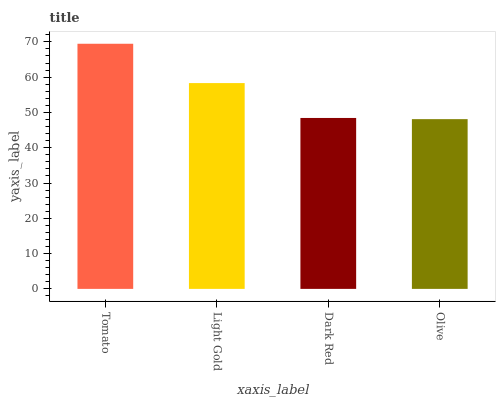Is Olive the minimum?
Answer yes or no. Yes. Is Tomato the maximum?
Answer yes or no. Yes. Is Light Gold the minimum?
Answer yes or no. No. Is Light Gold the maximum?
Answer yes or no. No. Is Tomato greater than Light Gold?
Answer yes or no. Yes. Is Light Gold less than Tomato?
Answer yes or no. Yes. Is Light Gold greater than Tomato?
Answer yes or no. No. Is Tomato less than Light Gold?
Answer yes or no. No. Is Light Gold the high median?
Answer yes or no. Yes. Is Dark Red the low median?
Answer yes or no. Yes. Is Tomato the high median?
Answer yes or no. No. Is Light Gold the low median?
Answer yes or no. No. 